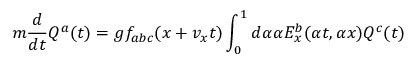Convert formula to latex. <formula><loc_0><loc_0><loc_500><loc_500>m { \frac { d } { d t } } Q ^ { a } ( t ) = g f _ { a b c } ( x + v _ { x } t ) \int _ { 0 } ^ { 1 } d \alpha \alpha E _ { x } ^ { b } ( \alpha t , \alpha x ) Q ^ { c } ( t )</formula> 